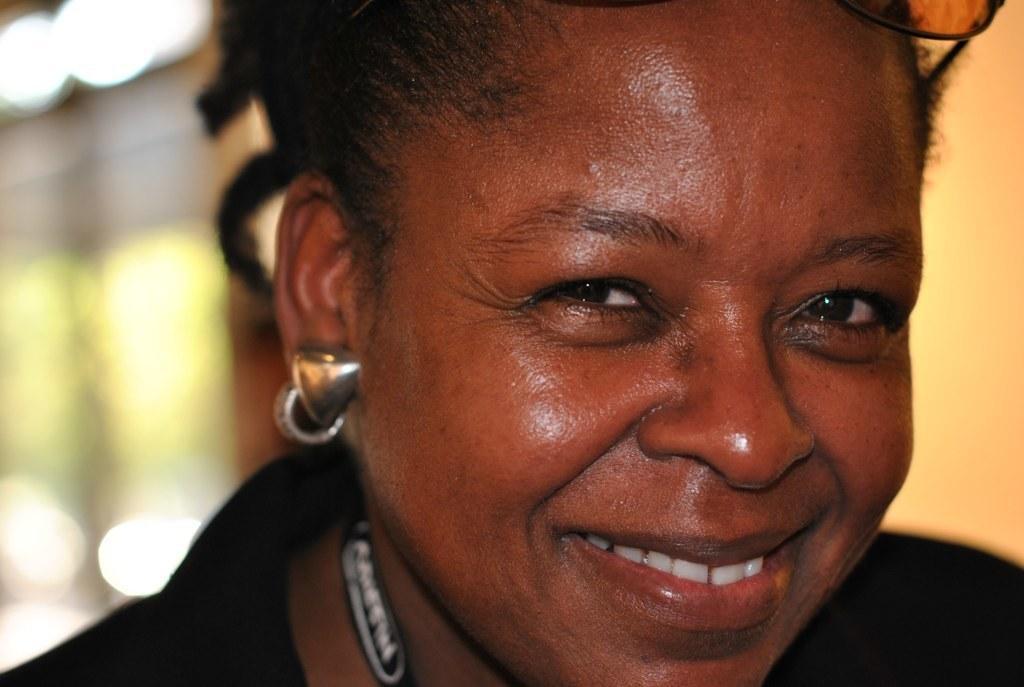Please provide a concise description of this image. In this picture we can see a woman smiling. Background is blurry. 